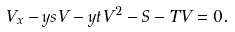<formula> <loc_0><loc_0><loc_500><loc_500>V _ { x } - y s V - y t V ^ { 2 } - S - T V = 0 .</formula> 